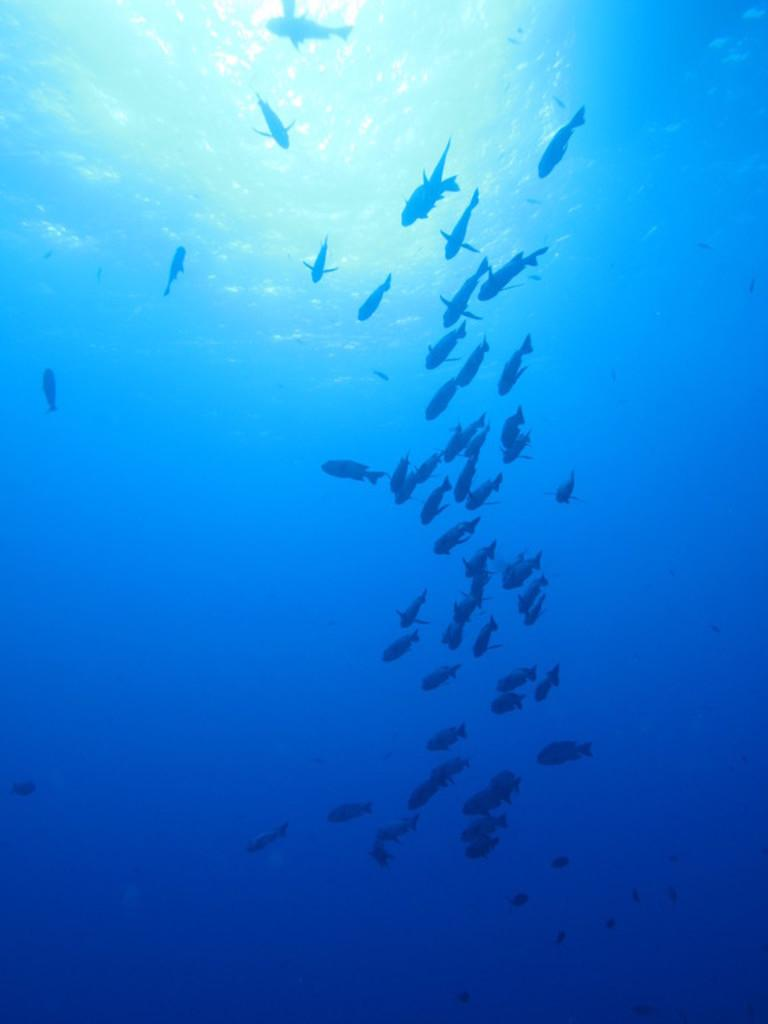What type of animals can be seen in the water? Fishes can be seen in the water. What is the primary element in which the fishes are situated? The fishes are situated in water. What type of iron can be seen in the image? There is no iron present in the image; it features fishes in the water. 